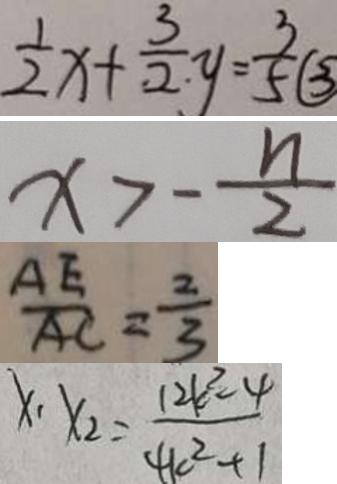<formula> <loc_0><loc_0><loc_500><loc_500>\frac { 1 } { 2 } x + \frac { 3 } { 2 } y = \frac { 3 } { 5 } \textcircled { 3 } 
 x > - \frac { n } { 2 } 
 \frac { A E } { A C } = \frac { 2 } { 3 } 
 x _ { 1 } \cdot x _ { 2 } = \frac { 1 2 k ^ { 2 } - 4 } { 4 k ^ { 2 } + 1 }</formula> 